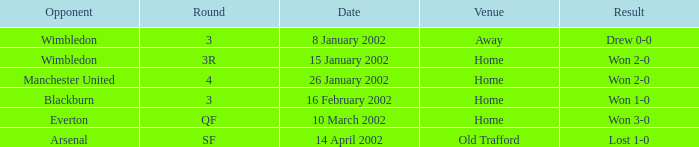What is the Opponent with a Round with 3, and a Venue of home? Blackburn. 